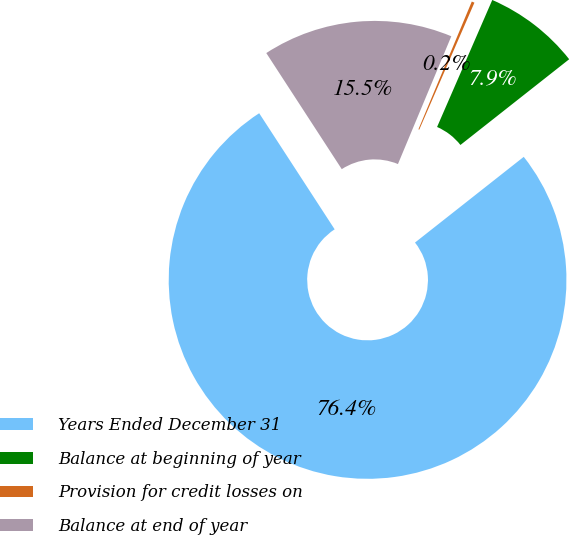Convert chart to OTSL. <chart><loc_0><loc_0><loc_500><loc_500><pie_chart><fcel>Years Ended December 31<fcel>Balance at beginning of year<fcel>Provision for credit losses on<fcel>Balance at end of year<nl><fcel>76.45%<fcel>7.85%<fcel>0.23%<fcel>15.47%<nl></chart> 